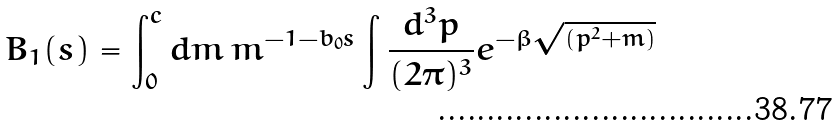<formula> <loc_0><loc_0><loc_500><loc_500>B _ { 1 } ( s ) = \int _ { 0 } ^ { c } d m \, m ^ { - 1 - b _ { 0 } s } \int \frac { d ^ { 3 } p } { ( 2 \pi ) ^ { 3 } } e ^ { - \beta \sqrt { ( p ^ { 2 } + m ) } }</formula> 